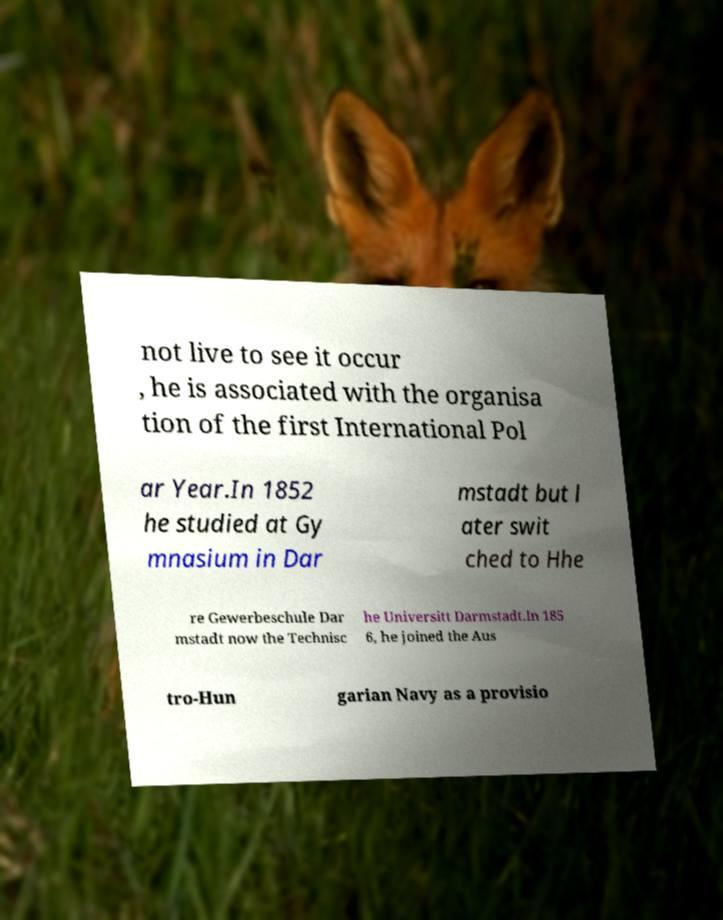Could you assist in decoding the text presented in this image and type it out clearly? not live to see it occur , he is associated with the organisa tion of the first International Pol ar Year.In 1852 he studied at Gy mnasium in Dar mstadt but l ater swit ched to Hhe re Gewerbeschule Dar mstadt now the Technisc he Universitt Darmstadt.In 185 6, he joined the Aus tro-Hun garian Navy as a provisio 